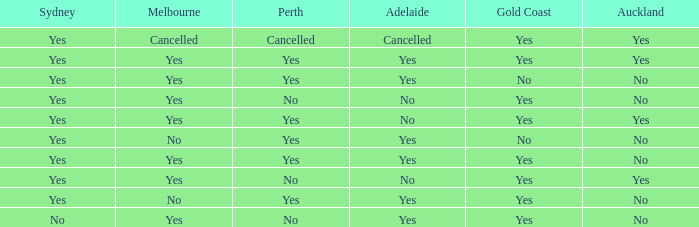What is meant by "the melbourne lacking a gold coast"? Yes, No. 